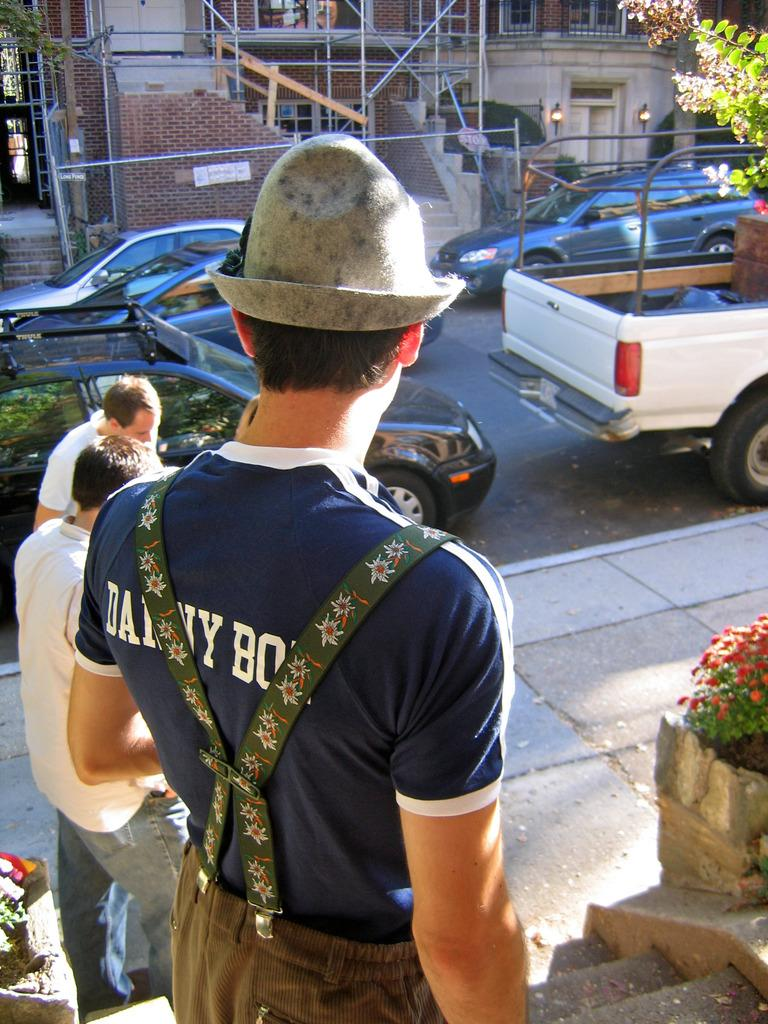How many people are present in the image? There are three persons standing in the image. What can be seen in the image besides the people? There are plants, flowers, cars parked on the road, a building, and a person wearing a hat in the image. Can you describe the plants and flowers in the image? The image contains plants and flowers, but specific details about their types or colors are not provided. What is the location of the building in the image? The building is in the image, but its exact location relative to the other elements is not specified. What type of goat can be seen in the image? There is no goat present in the image. How does the person wearing a hat feel about the situation in the image? The image does not provide any information about the person's feelings or emotions, so it cannot be determined from the image. 